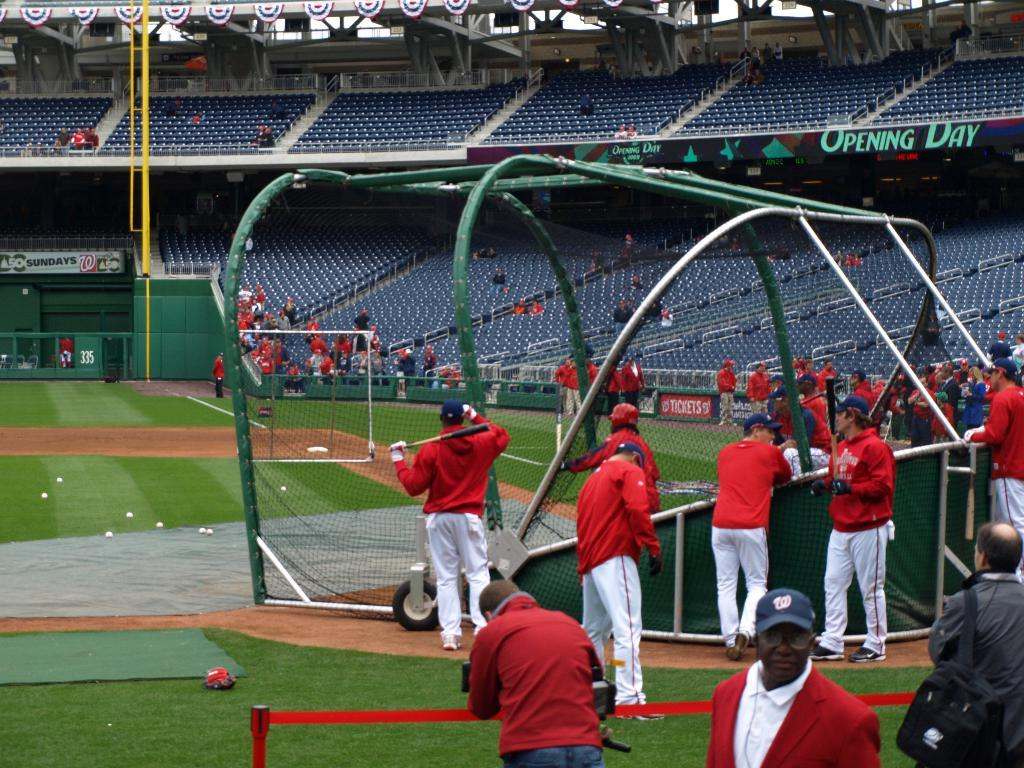Who or what can be seen in the image? There are people in the image. What object is present in the image that is used for catching or blocking? There is a net in the image. What type of seating can be seen in the background of the image? There are bleachers in the background of the image. What architectural feature is visible in the background of the image? There is a gate in the background of the image. How many mice are running around on the bleachers in the image? There are no mice present in the image; it only features people, a net, bleachers, and a gate. What star is shining brightly in the sky above the gate in the image? There is no star visible in the image, as it only shows people, a net, bleachers, and a gate. 